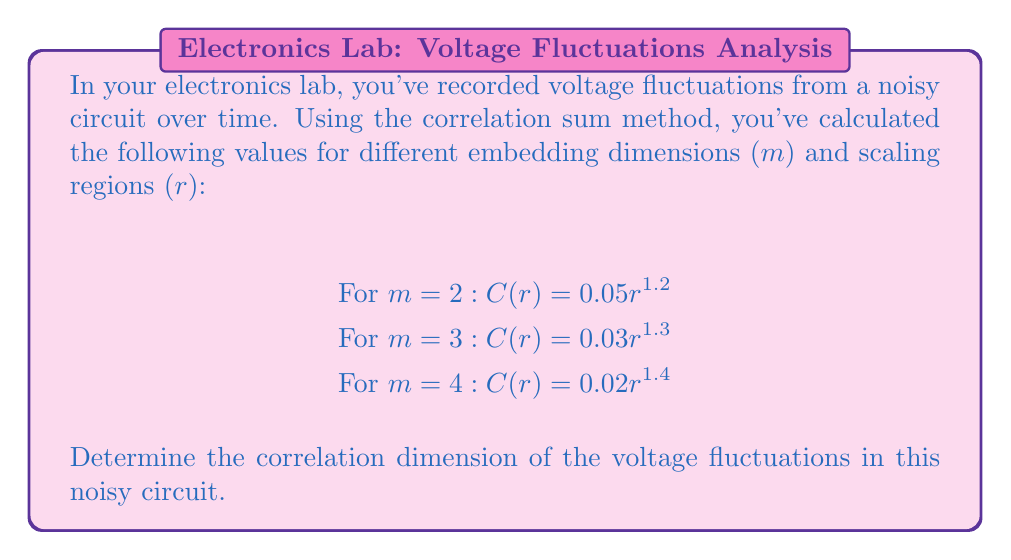Give your solution to this math problem. To determine the correlation dimension, we'll follow these steps:

1) The correlation sum $C(r)$ is related to the scaling region r by the power law:

   $C(r) \propto r^D$

   where D is the correlation dimension.

2) Taking the logarithm of both sides:

   $\log C(r) = D \log r + \text{constant}$

3) The slope of $\log C(r)$ vs $\log r$ gives us the correlation dimension D.

4) From the given data, we can see that as m increases, the exponent (which represents D) also increases:

   For m = 2: D ≈ 1.2
   For m = 3: D ≈ 1.3
   For m = 4: D ≈ 1.4

5) In chaos theory, we're interested in the limit of D as m approaches infinity. However, in practice, we look for the value where D starts to saturate.

6) In this case, we can see that D is still increasing with m, but the rate of increase is slowing down.

7) A common approach is to estimate the correlation dimension as the highest observed D value, which in this case is 1.4.

Therefore, based on the given data, we estimate the correlation dimension of the voltage fluctuations to be approximately 1.4.
Answer: 1.4 